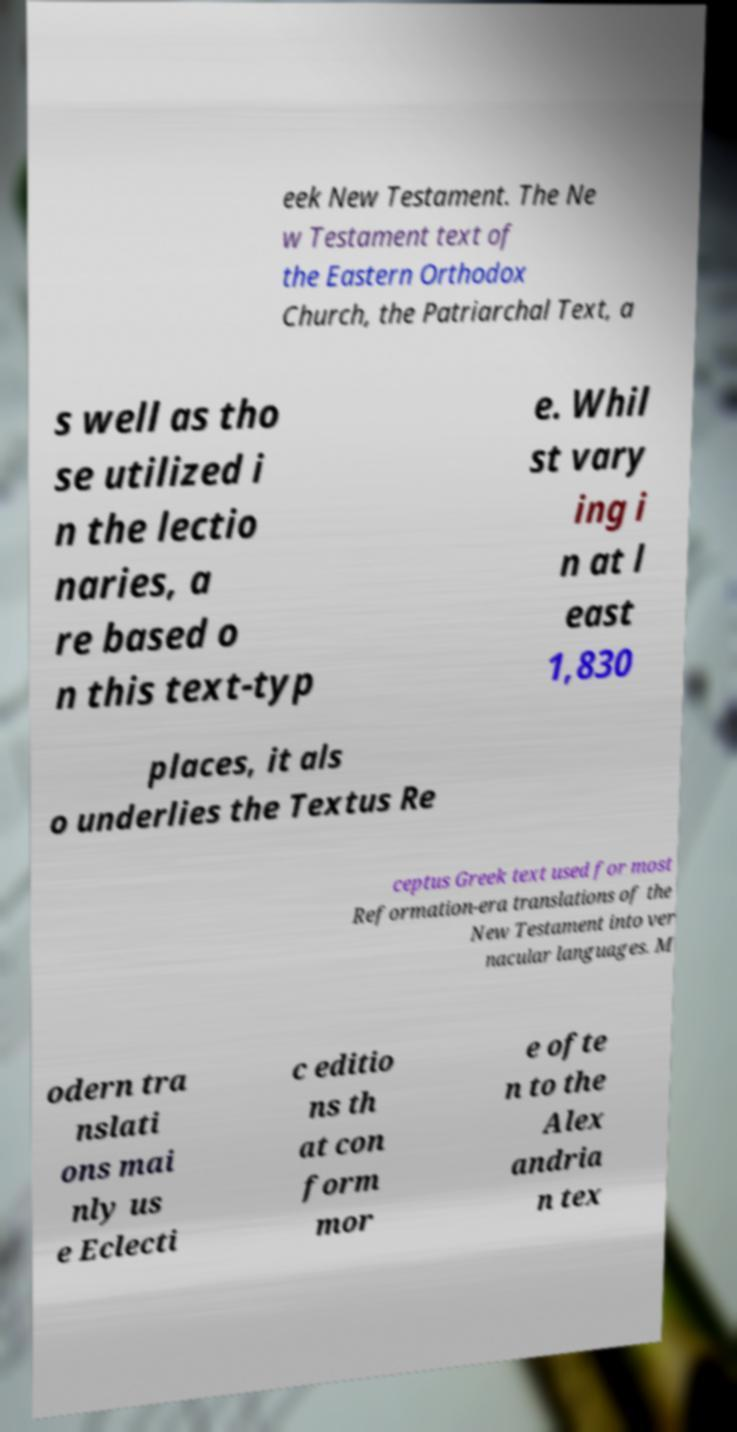There's text embedded in this image that I need extracted. Can you transcribe it verbatim? eek New Testament. The Ne w Testament text of the Eastern Orthodox Church, the Patriarchal Text, a s well as tho se utilized i n the lectio naries, a re based o n this text-typ e. Whil st vary ing i n at l east 1,830 places, it als o underlies the Textus Re ceptus Greek text used for most Reformation-era translations of the New Testament into ver nacular languages. M odern tra nslati ons mai nly us e Eclecti c editio ns th at con form mor e ofte n to the Alex andria n tex 